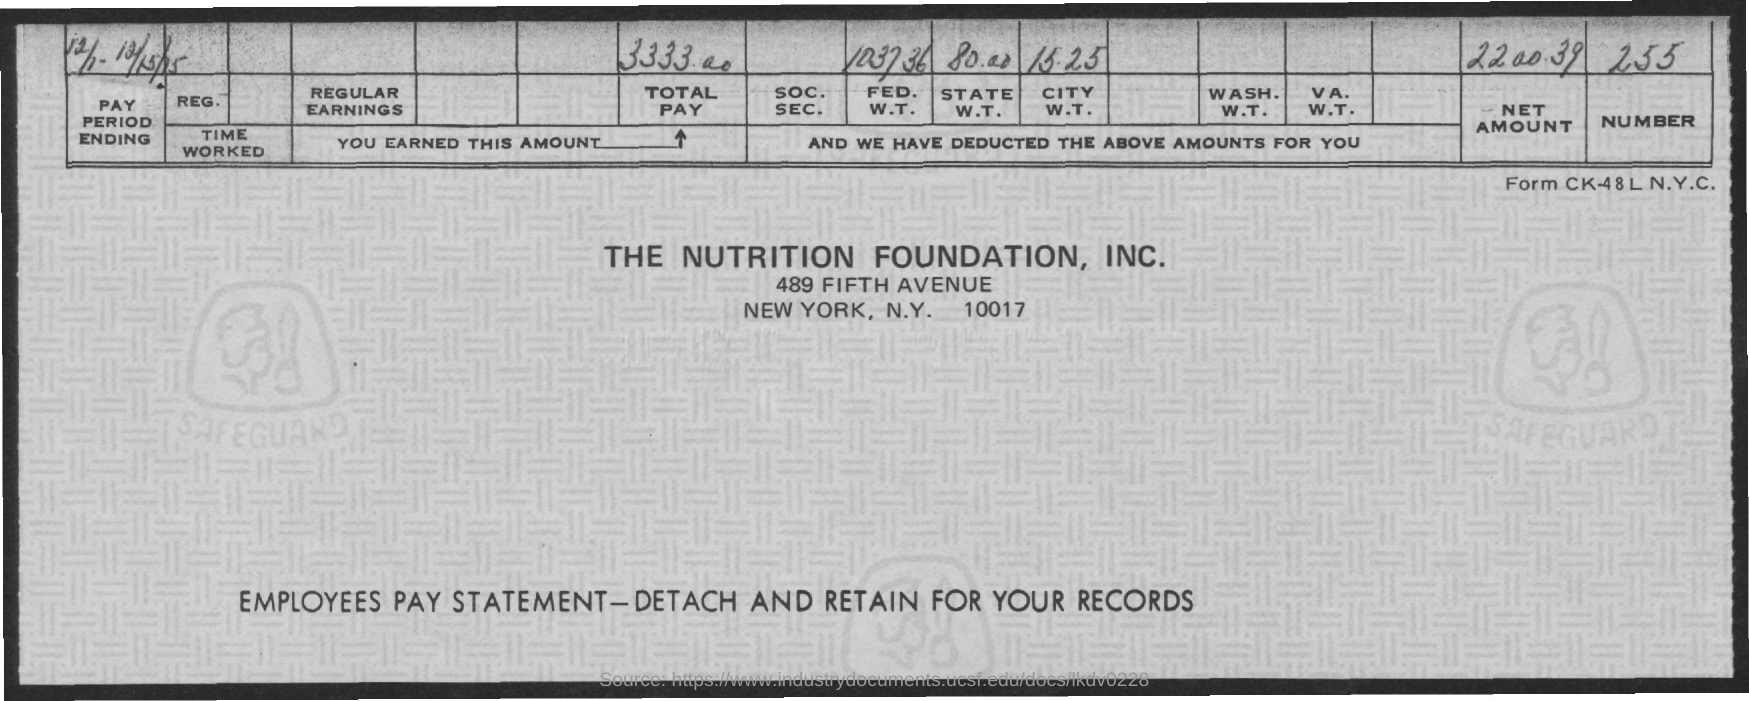Specify some key components in this picture. The total pay mentioned on the given page is 3333.00. The number mentioned in the given page is 255. The net amount mentioned in the given page is 2,200.39. The amount for state W.T. mentioned in the given page is 80.00. The amount for FED. W.T. mentioned on the given page is 1037.36. 